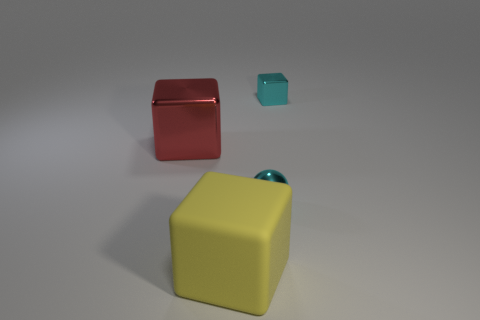Is the color of the ball that is in front of the cyan block the same as the metallic cube that is on the right side of the cyan shiny ball?
Offer a very short reply. Yes. How many large blocks are the same material as the small cube?
Provide a succinct answer. 1. There is a small thing in front of the small cube; what number of small cyan balls are to the left of it?
Your answer should be very brief. 0. How many rubber objects are there?
Give a very brief answer. 1. Do the small ball and the big red cube that is in front of the cyan cube have the same material?
Keep it short and to the point. Yes. There is a cube that is on the right side of the yellow cube; is its color the same as the shiny ball?
Give a very brief answer. Yes. What is the thing that is on the right side of the big shiny object and left of the tiny metal sphere made of?
Your answer should be compact. Rubber. What size is the red block?
Offer a very short reply. Large. There is a tiny block; is it the same color as the tiny sphere behind the matte object?
Offer a terse response. Yes. What number of other things are the same color as the tiny sphere?
Provide a succinct answer. 1. 